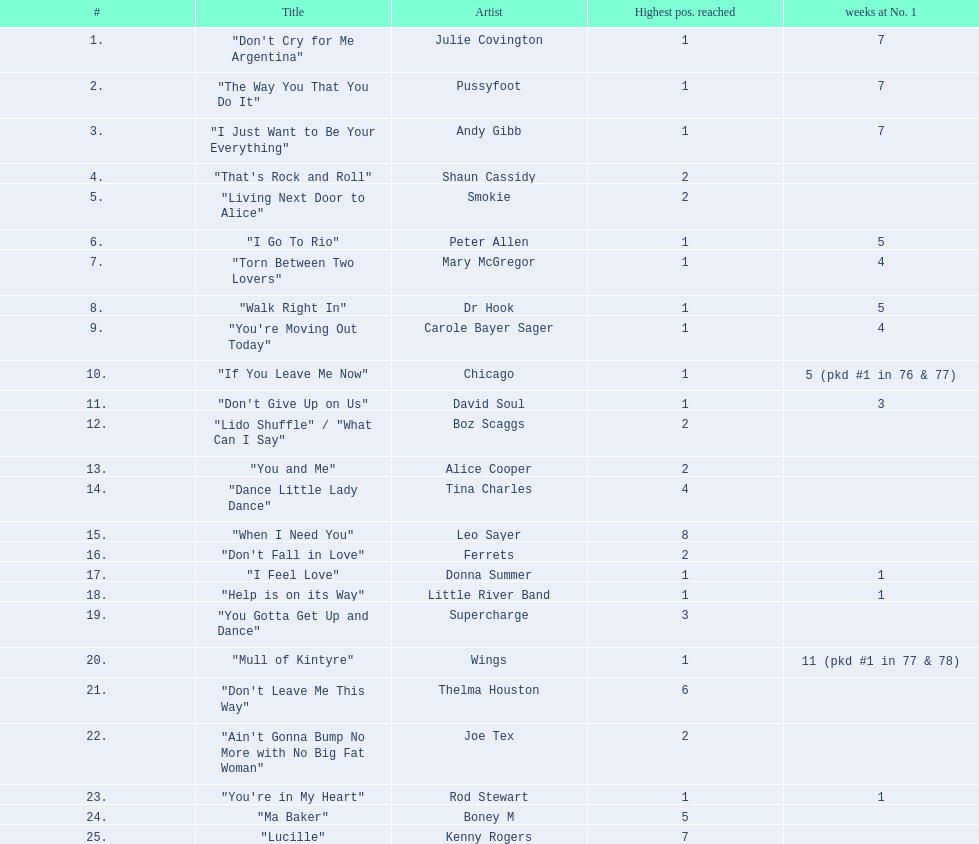What's the longest time a song has been at number 1? 11 (pkd #1 in 77 & 78). Which song had an 11-week run at the top position? "Mull of Kintyre". Which band scored a number 1 hit with their song? Wings. 